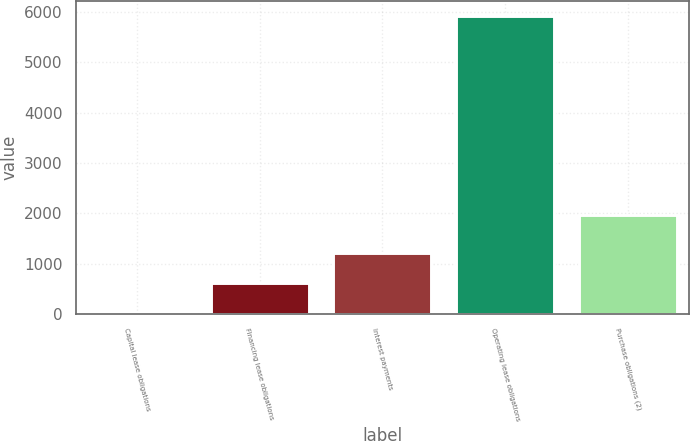Convert chart to OTSL. <chart><loc_0><loc_0><loc_500><loc_500><bar_chart><fcel>Capital lease obligations<fcel>Financing lease obligations<fcel>Interest payments<fcel>Operating lease obligations<fcel>Purchase obligations (2)<nl><fcel>27<fcel>617.1<fcel>1207.2<fcel>5928<fcel>1968<nl></chart> 